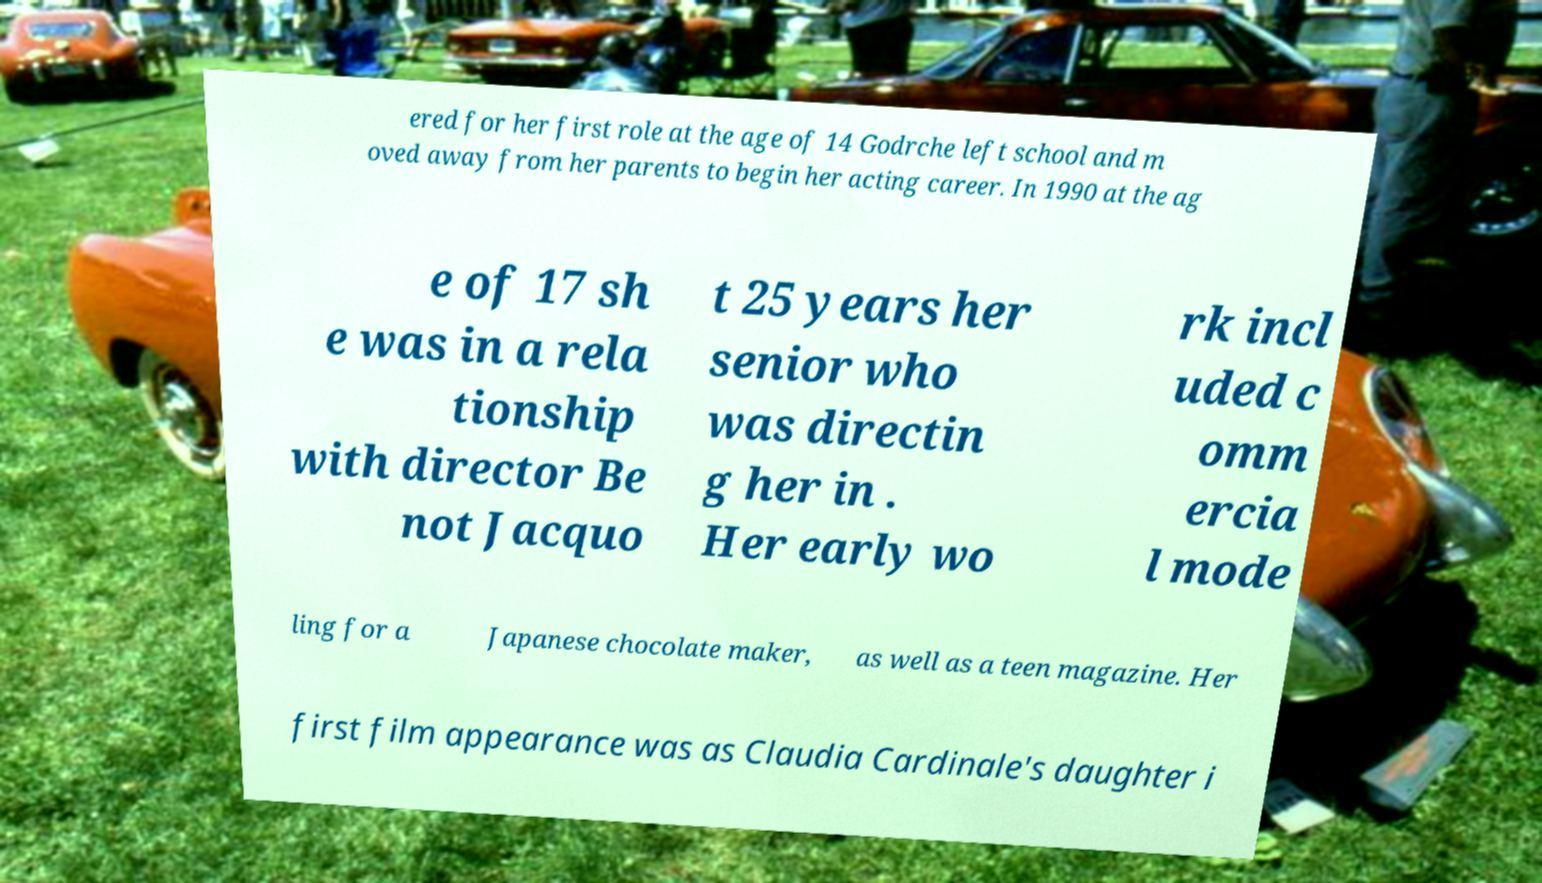What messages or text are displayed in this image? I need them in a readable, typed format. ered for her first role at the age of 14 Godrche left school and m oved away from her parents to begin her acting career. In 1990 at the ag e of 17 sh e was in a rela tionship with director Be not Jacquo t 25 years her senior who was directin g her in . Her early wo rk incl uded c omm ercia l mode ling for a Japanese chocolate maker, as well as a teen magazine. Her first film appearance was as Claudia Cardinale's daughter i 